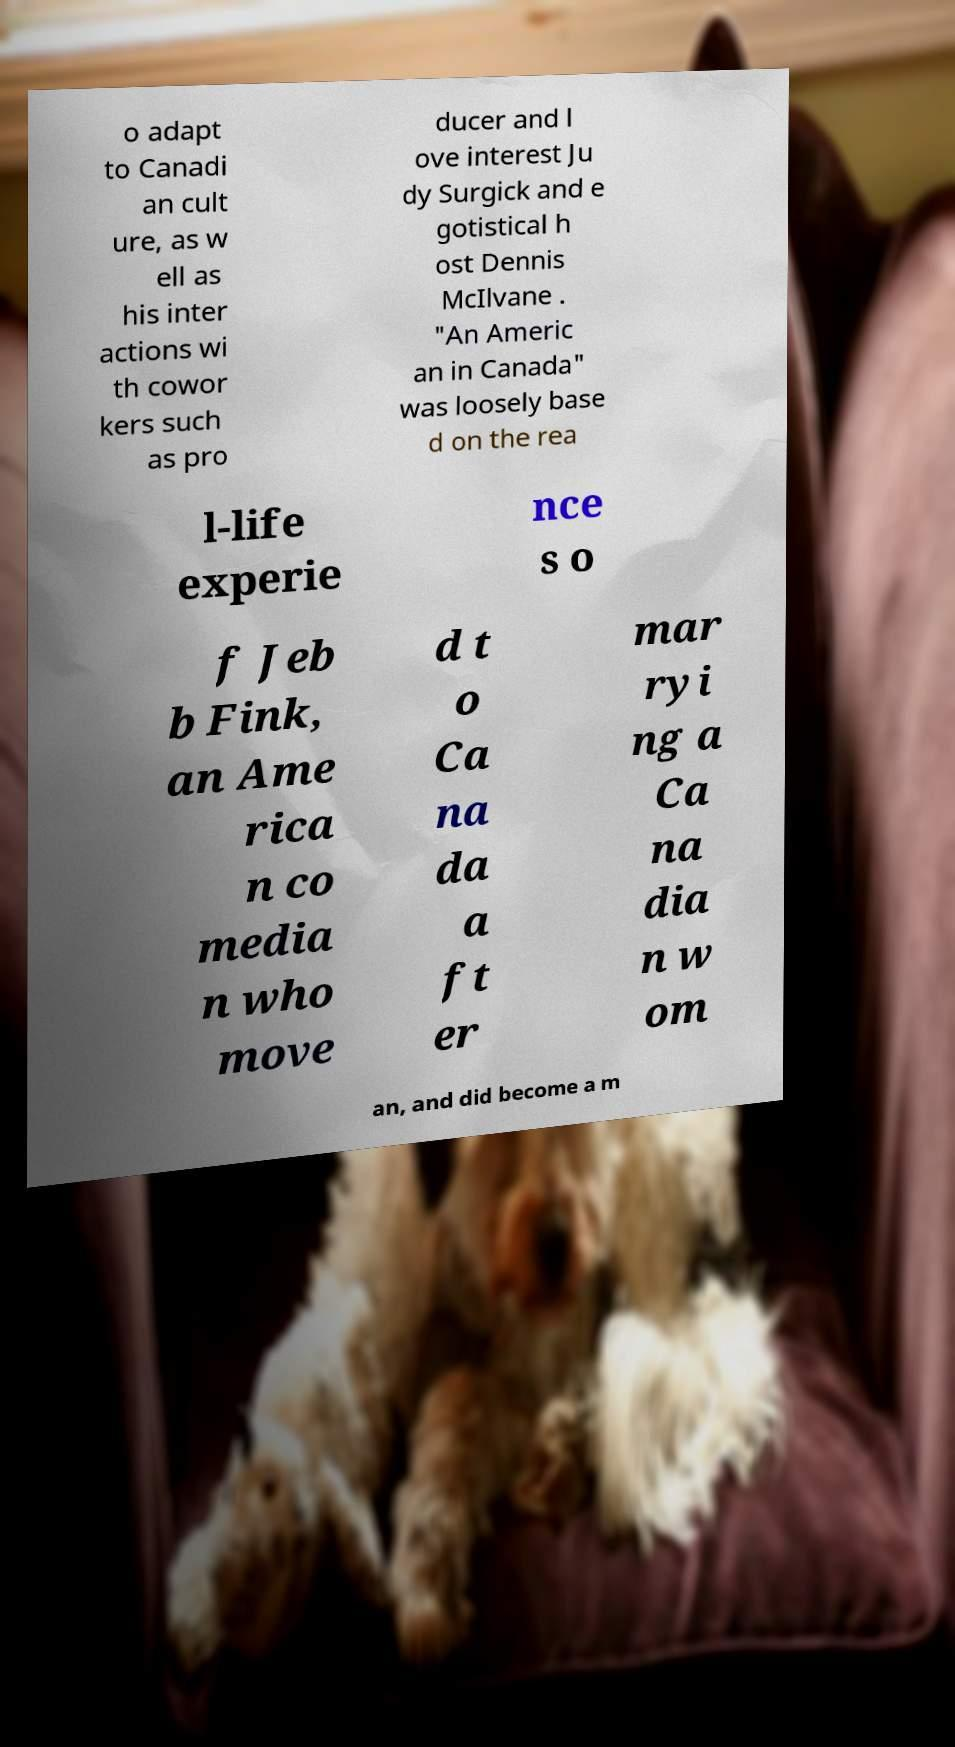I need the written content from this picture converted into text. Can you do that? o adapt to Canadi an cult ure, as w ell as his inter actions wi th cowor kers such as pro ducer and l ove interest Ju dy Surgick and e gotistical h ost Dennis McIlvane . "An Americ an in Canada" was loosely base d on the rea l-life experie nce s o f Jeb b Fink, an Ame rica n co media n who move d t o Ca na da a ft er mar ryi ng a Ca na dia n w om an, and did become a m 